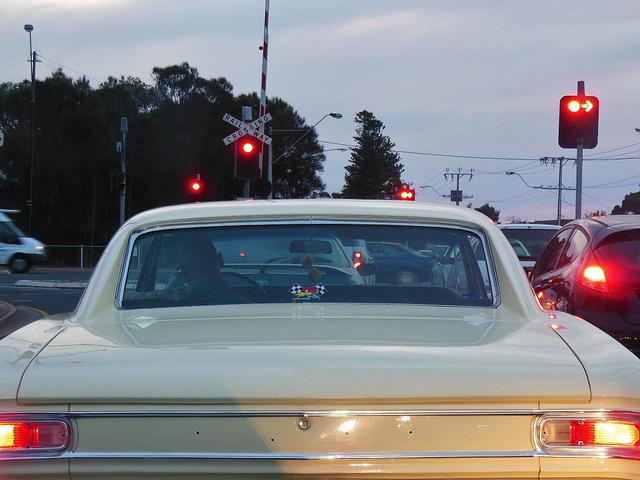There are a line of cars at the intersection because of what reason?

Choices:
A) emergency vehicle
B) traffic light
C) approaching train
D) traffic jam traffic light 